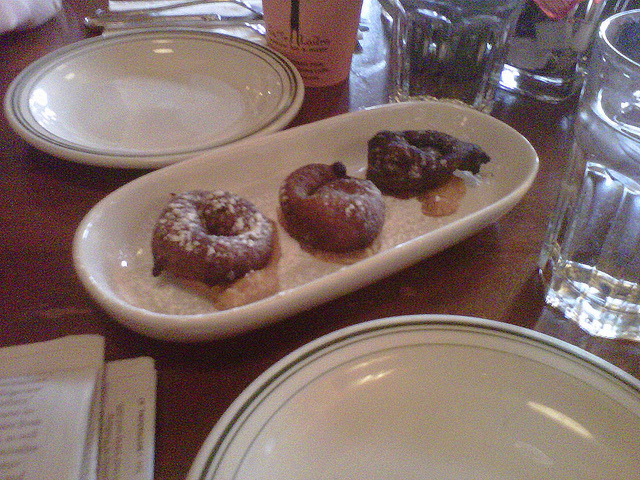Could these donuts be homemade or store-bought? Given their unique shapes and different toppings, it's possible these donuts are homemade, showcasing a more personal touch. Alternatively, they might come from a local bakery that offers handcrafted varieties. 